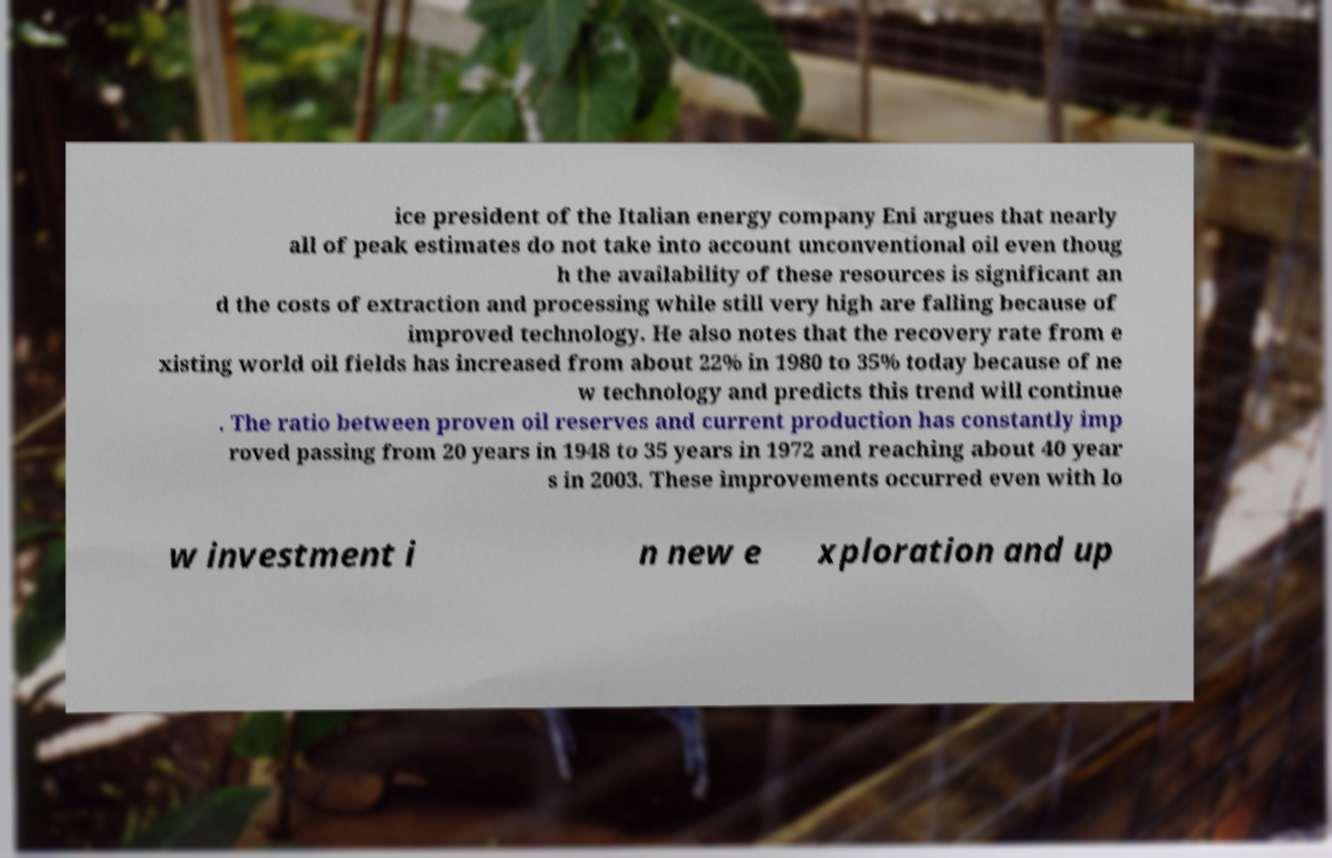There's text embedded in this image that I need extracted. Can you transcribe it verbatim? ice president of the Italian energy company Eni argues that nearly all of peak estimates do not take into account unconventional oil even thoug h the availability of these resources is significant an d the costs of extraction and processing while still very high are falling because of improved technology. He also notes that the recovery rate from e xisting world oil fields has increased from about 22% in 1980 to 35% today because of ne w technology and predicts this trend will continue . The ratio between proven oil reserves and current production has constantly imp roved passing from 20 years in 1948 to 35 years in 1972 and reaching about 40 year s in 2003. These improvements occurred even with lo w investment i n new e xploration and up 